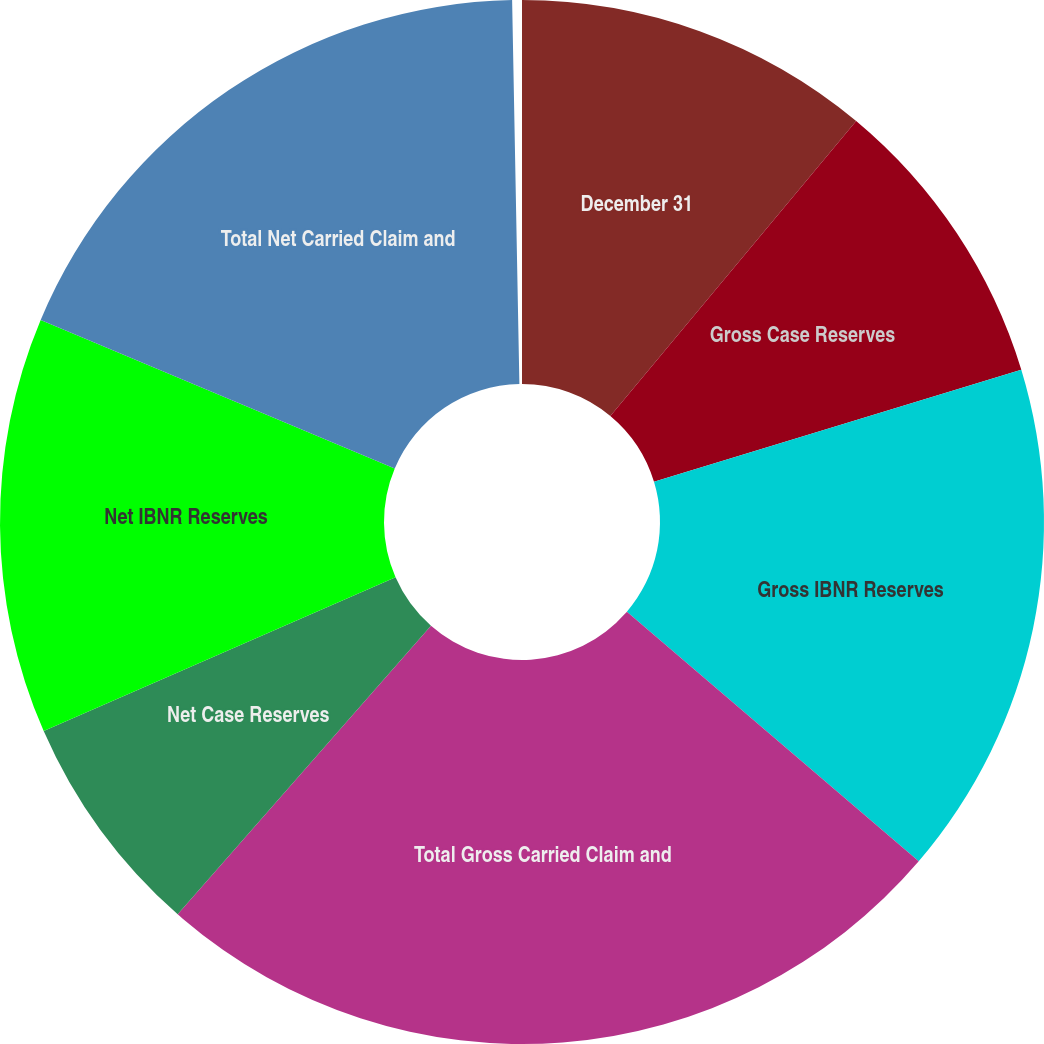Convert chart to OTSL. <chart><loc_0><loc_0><loc_500><loc_500><pie_chart><fcel>December 31<fcel>Gross Case Reserves<fcel>Gross IBNR Reserves<fcel>Total Gross Carried Claim and<fcel>Net Case Reserves<fcel>Net IBNR Reserves<fcel>Total Net Carried Claim and<nl><fcel>11.09%<fcel>9.26%<fcel>16.02%<fcel>25.28%<fcel>7.0%<fcel>12.92%<fcel>18.43%<nl></chart> 